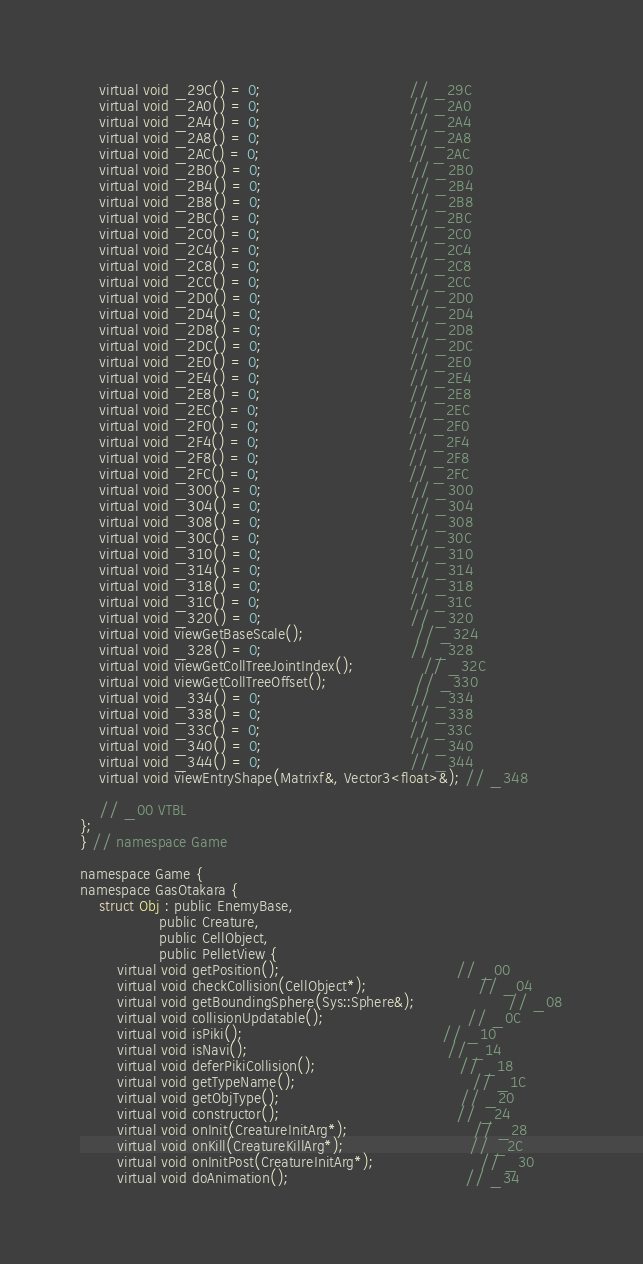Convert code to text. <code><loc_0><loc_0><loc_500><loc_500><_C_>	virtual void _29C() = 0;                                // _29C
	virtual void _2A0() = 0;                                // _2A0
	virtual void _2A4() = 0;                                // _2A4
	virtual void _2A8() = 0;                                // _2A8
	virtual void _2AC() = 0;                                // _2AC
	virtual void _2B0() = 0;                                // _2B0
	virtual void _2B4() = 0;                                // _2B4
	virtual void _2B8() = 0;                                // _2B8
	virtual void _2BC() = 0;                                // _2BC
	virtual void _2C0() = 0;                                // _2C0
	virtual void _2C4() = 0;                                // _2C4
	virtual void _2C8() = 0;                                // _2C8
	virtual void _2CC() = 0;                                // _2CC
	virtual void _2D0() = 0;                                // _2D0
	virtual void _2D4() = 0;                                // _2D4
	virtual void _2D8() = 0;                                // _2D8
	virtual void _2DC() = 0;                                // _2DC
	virtual void _2E0() = 0;                                // _2E0
	virtual void _2E4() = 0;                                // _2E4
	virtual void _2E8() = 0;                                // _2E8
	virtual void _2EC() = 0;                                // _2EC
	virtual void _2F0() = 0;                                // _2F0
	virtual void _2F4() = 0;                                // _2F4
	virtual void _2F8() = 0;                                // _2F8
	virtual void _2FC() = 0;                                // _2FC
	virtual void _300() = 0;                                // _300
	virtual void _304() = 0;                                // _304
	virtual void _308() = 0;                                // _308
	virtual void _30C() = 0;                                // _30C
	virtual void _310() = 0;                                // _310
	virtual void _314() = 0;                                // _314
	virtual void _318() = 0;                                // _318
	virtual void _31C() = 0;                                // _31C
	virtual void _320() = 0;                                // _320
	virtual void viewGetBaseScale();                        // _324
	virtual void _328() = 0;                                // _328
	virtual void viewGetCollTreeJointIndex();               // _32C
	virtual void viewGetCollTreeOffset();                   // _330
	virtual void _334() = 0;                                // _334
	virtual void _338() = 0;                                // _338
	virtual void _33C() = 0;                                // _33C
	virtual void _340() = 0;                                // _340
	virtual void _344() = 0;                                // _344
	virtual void viewEntryShape(Matrixf&, Vector3<float>&); // _348

	// _00 VTBL
};
} // namespace Game

namespace Game {
namespace GasOtakara {
	struct Obj : public EnemyBase,
	             public Creature,
	             public CellObject,
	             public PelletView {
		virtual void getPosition();                                      // _00
		virtual void checkCollision(CellObject*);                        // _04
		virtual void getBoundingSphere(Sys::Sphere&);                    // _08
		virtual void collisionUpdatable();                               // _0C
		virtual void isPiki();                                           // _10
		virtual void isNavi();                                           // _14
		virtual void deferPikiCollision();                               // _18
		virtual void getTypeName();                                      // _1C
		virtual void getObjType();                                       // _20
		virtual void constructor();                                      // _24
		virtual void onInit(CreatureInitArg*);                           // _28
		virtual void onKill(CreatureKillArg*);                           // _2C
		virtual void onInitPost(CreatureInitArg*);                       // _30
		virtual void doAnimation();                                      // _34</code> 